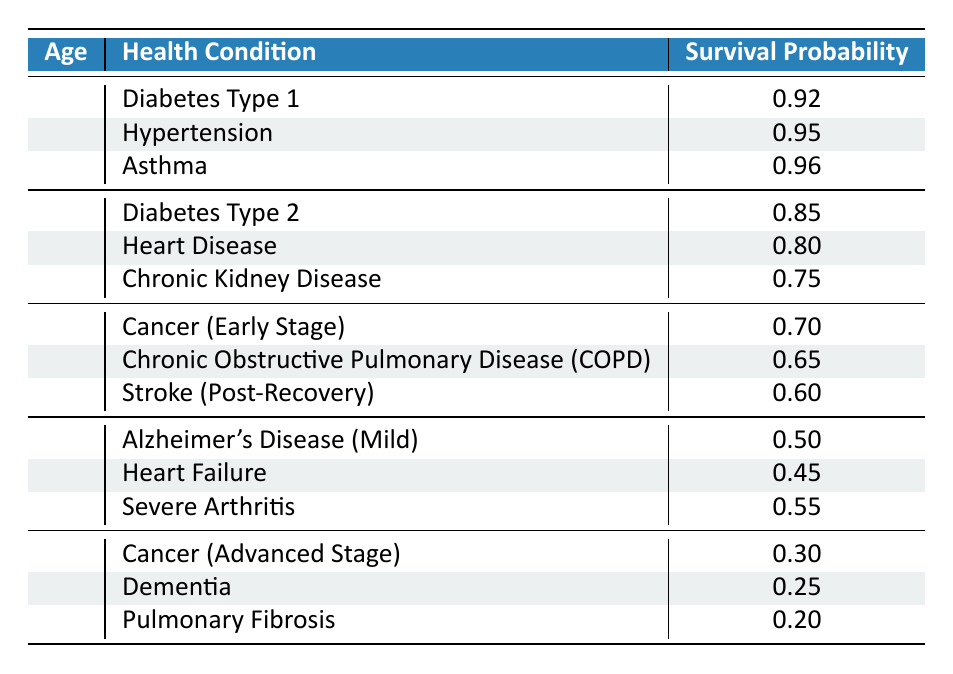What is the survival probability for a 30-year-old with asthma? The survival probability for a 30-year-old with asthma is explicitly listed in the table. Looking at the row for age 30 and finding the condition "Asthma," the corresponding survival probability is 0.96.
Answer: 0.96 What is the lowest survival probability for a health condition at age 60? To find the lowest survival probability for a 60-year-old, we examine the health conditions listed for that age group: Alzheimer's Disease (Mild) is 0.50, Heart Failure is 0.45, and Severe Arthritis is 0.55. The lowest of these is 0.45 for Heart Failure.
Answer: 0.45 Is the survival probability for chronic kidney disease greater than 0.70? Checking the survival probability for Chronic Kidney Disease, which is listed as 0.75 in the relevant row for age 40, we see that 0.75 is indeed greater than 0.70.
Answer: Yes What is the average survival probability for individuals aged 50? The survival probabilities for age 50 are: Cancer (Early Stage) 0.70, Chronic Obstructive Pulmonary Disease 0.65, and Stroke (Post-Recovery) 0.60. We sum these values (0.70 + 0.65 + 0.60 = 1.95) and divide by 3 (1.95 / 3 = 0.65) to get the average.
Answer: 0.65 Which health condition has the highest survival probability at age 40? Reviewing the age 40 group, the health conditions and their survival probabilities are as follows: Diabetes Type 2 (0.85), Heart Disease (0.80), and Chronic Kidney Disease (0.75). The highest value is 0.85 for Diabetes Type 2.
Answer: Diabetes Type 2 What is the total number of health conditions listed for individuals aged 70? There are three health conditions listed for the 70-year-old age group: Cancer (Advanced Stage), Dementia, and Pulmonary Fibrosis. Since there are no additional conditions mentioned, the total is simply 3.
Answer: 3 Is the survival probability for Alzheimer's Disease (Mild) higher than that for Chronic Obstructive Pulmonary Disease? From the table, the survival probability for Alzheimer's Disease (Mild) is 0.50, while the survival probability for Chronic Obstructive Pulmonary Disease is 0.65. Since 0.50 is less than 0.65, the statement is false.
Answer: No What is the difference in survival probabilities between Heart Failure and Cancer (Advanced Stage)? We first find the survival probability for Heart Failure, which is 0.45, and for Cancer (Advanced Stage), which is 0.30. The difference is calculated as follows: 0.45 - 0.30, resulting in 0.15.
Answer: 0.15 